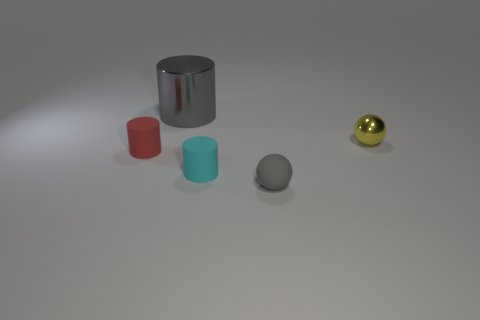Add 1 tiny yellow balls. How many objects exist? 6 Subtract all cylinders. How many objects are left? 2 Subtract all small cyan rubber cylinders. Subtract all red things. How many objects are left? 3 Add 1 large gray metallic things. How many large gray metallic things are left? 2 Add 4 cyan cylinders. How many cyan cylinders exist? 5 Subtract 0 red balls. How many objects are left? 5 